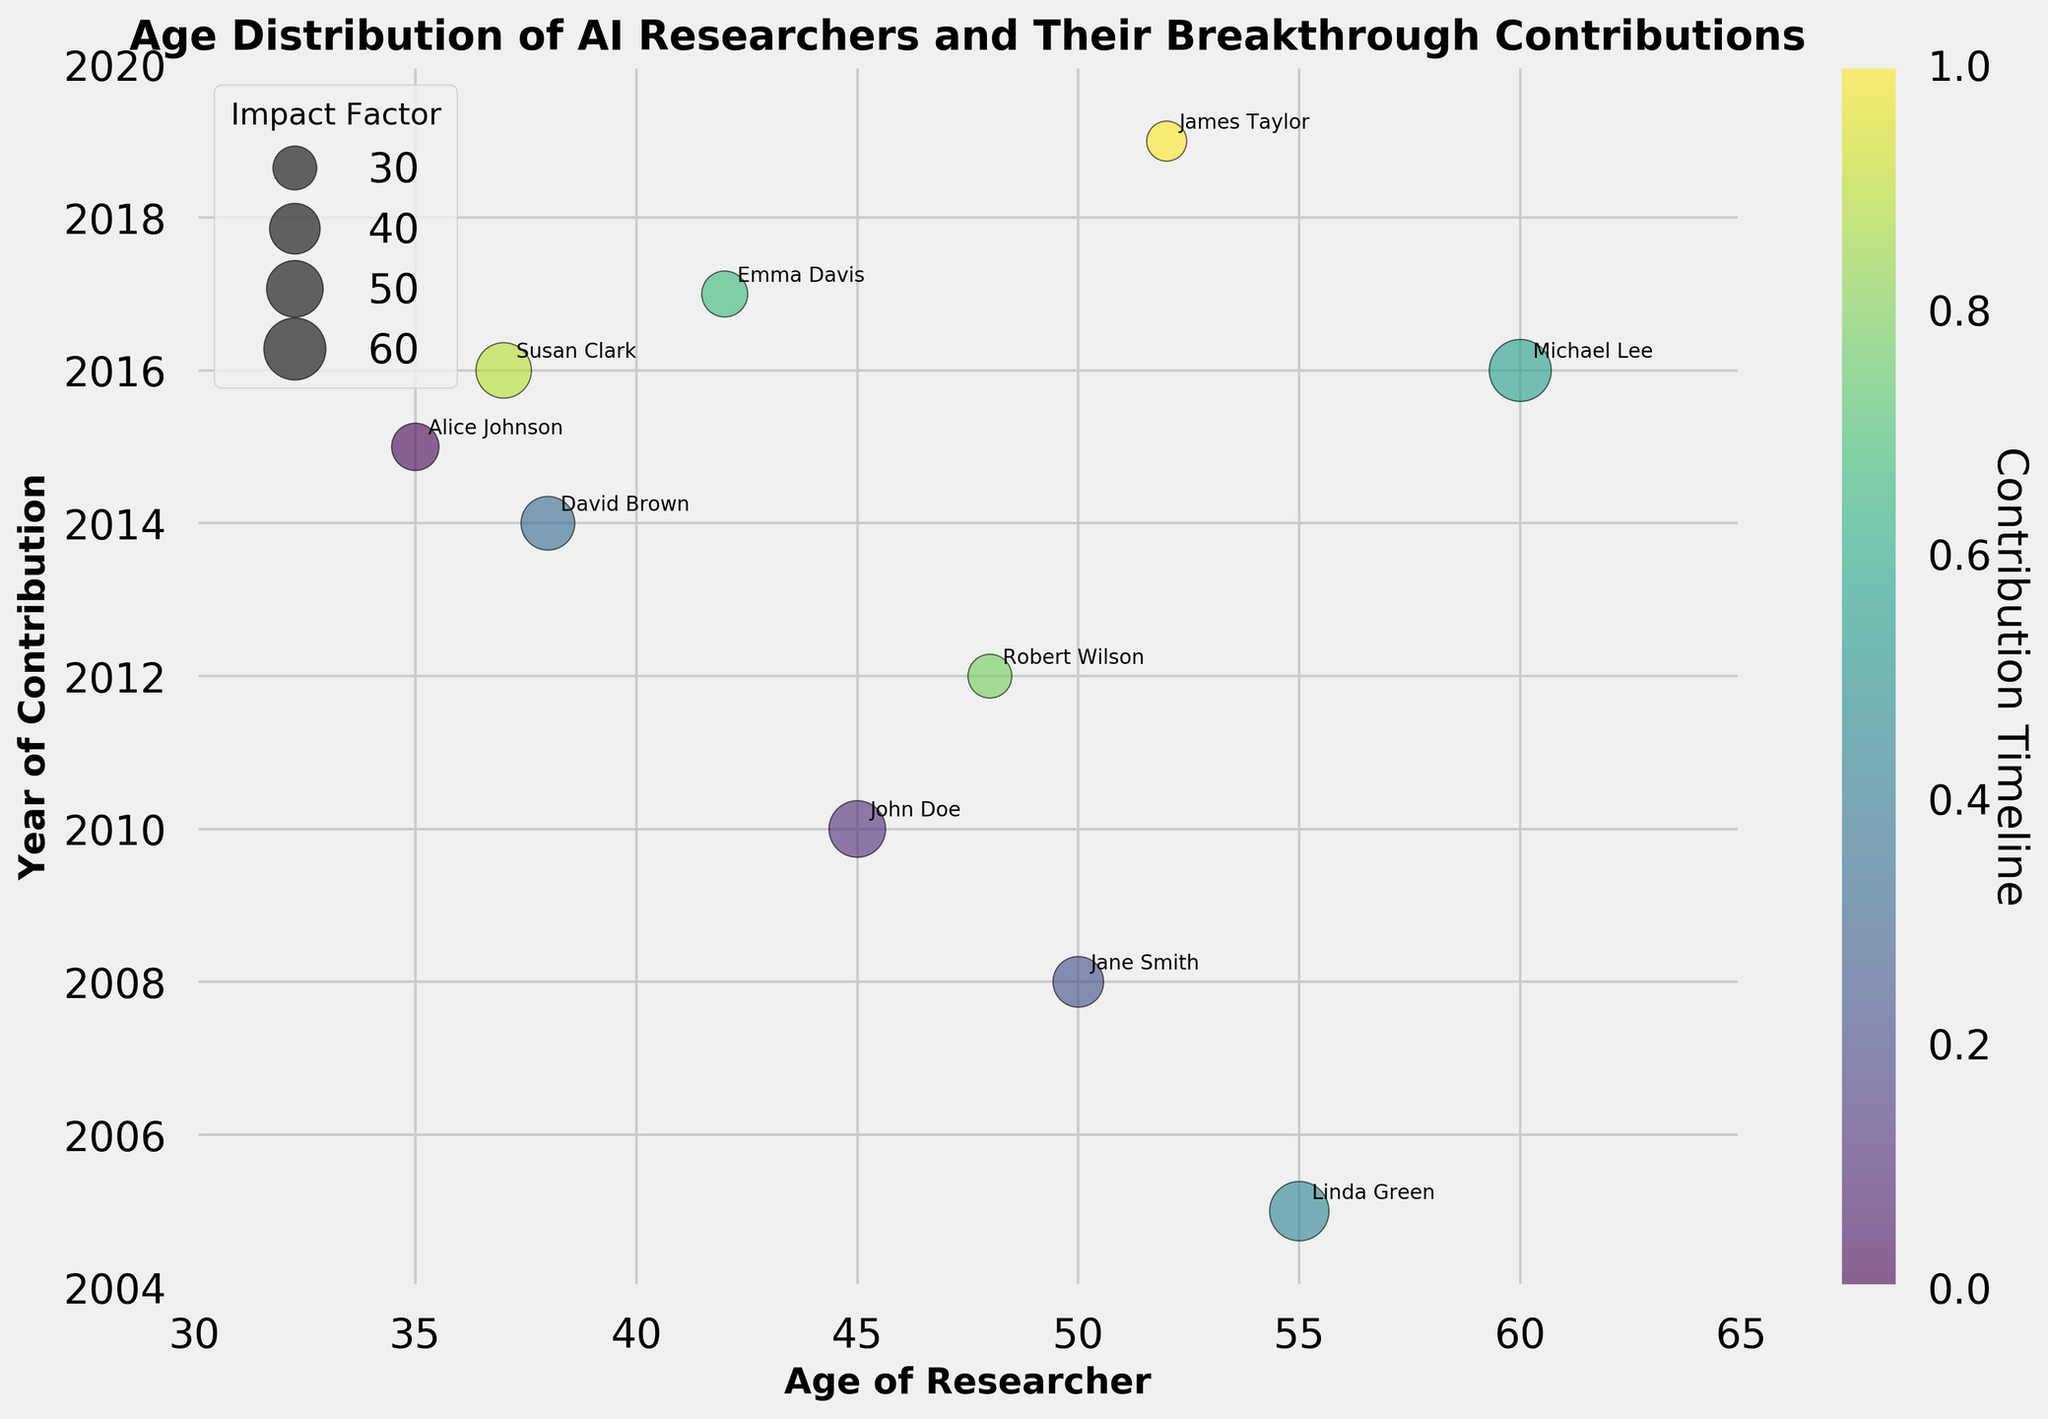What is the title of the chart? The title is displayed prominently at the top of the chart, indicating the main subject of the visualization. It reads, "Age Distribution of AI Researchers and Their Breakthrough Contributions".
Answer: Age Distribution of AI Researchers and Their Breakthrough Contributions What does the x-axis represent? The x-axis label beneath the horizontal line clearly states that it represents the "Age of Researcher", showing the age range of the researchers included in the chart.
Answer: Age of Researcher What does the y-axis represent? The y-axis label located along the vertical line of the chart specifies that it shows the "Year of Contribution", indicating when each researcher made their notable contribution.
Answer: Year of Contribution How many researchers are represented in the chart? By counting the distinct data points (bubbles) marked in the chart along with their annotations, one can determine that there are 10 researchers in total.
Answer: 10 Which researcher contributed to AI the earliest and in what year? The y-axis represents the timeline and the lowest data point (bubble) corresponds to the year 2005. The annotation next to this data point shows the researcher is Linda Green.
Answer: Linda Green, 2005 Who is the youngest researcher depicted in the chart and what was their contribution? The x-axis represents the age; the leftmost bubble corresponds to the age of 35. The annotation next to this bubble indicates the researcher is Alice Johnson, with the contribution being "Advanced Neural Networks".
Answer: Alice Johnson, Advanced Neural Networks Which researcher has the highest impact factor and which contribution did they make? The bubble size is proportional to the impact factor. The biggest bubble corresponds to the highest impact factor of 60. The annotation next to this bubble identifies the researcher as Michael Lee, with the contribution "TensorFlow Development".
Answer: Michael Lee, TensorFlow Development Comparing the contributions of John Doe and Robert Wilson, who made their contribution earlier and by how many years? John Doe's contribution is marked at the year 2010 on the y-axis, whereas Robert Wilson's is marked at 2012. Therefore, John Doe contributed 2 years earlier than Robert Wilson.
Answer: John Doe, by 2 years What is the average age of the researchers? Adding up the ages of all 10 researchers (35, 45, 50, 38, 55, 60, 42, 48, 37, 52) gives a total of 462. Dividing this by the number of researchers (10) gives the average age, which is 462/10.
Answer: 46.2 How does the color gradient inform us about the contributions timeline? The color gradient of the bubbles transitions from lighter to darker shades, aligned with a color bar indicating the timeline of contributions. This denotes that contributions made earlier are lighter in color, while more recent ones are darker.
Answer: Gradient from lighter to darker 